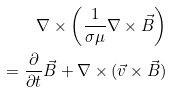<formula> <loc_0><loc_0><loc_500><loc_500>\nabla \times \left ( \frac { 1 } { \sigma \mu } \nabla \times \vec { B } \right ) \\ = \frac { \partial } { \partial t } \vec { B } + \nabla \times ( \vec { v } \times \vec { B } )</formula> 